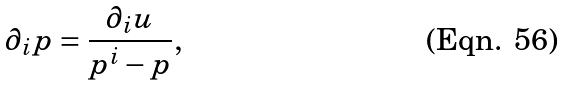Convert formula to latex. <formula><loc_0><loc_0><loc_500><loc_500>\partial _ { i } p = \frac { \partial _ { i } u } { p ^ { i } - p } ,</formula> 